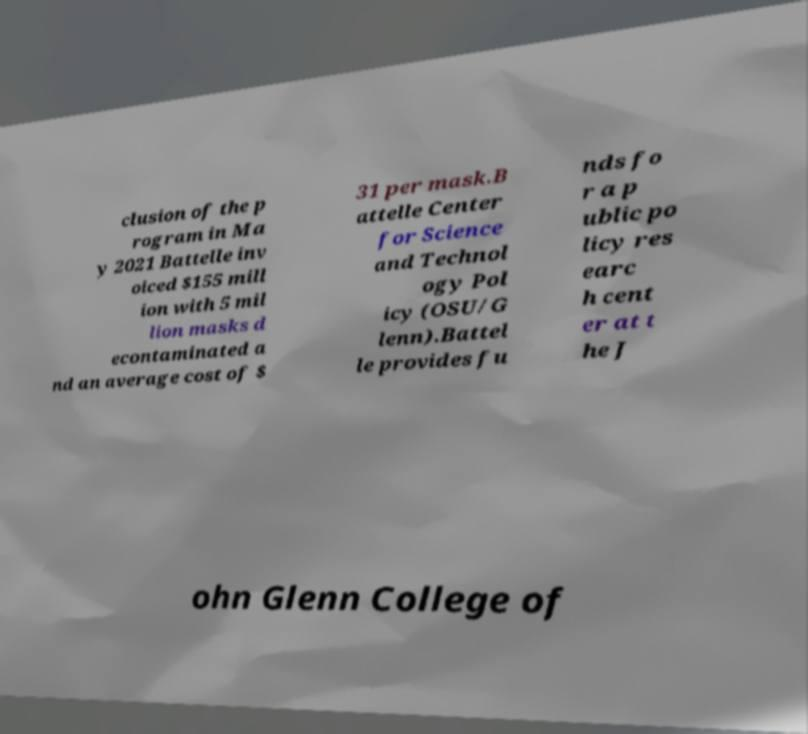Could you assist in decoding the text presented in this image and type it out clearly? clusion of the p rogram in Ma y 2021 Battelle inv oiced $155 mill ion with 5 mil lion masks d econtaminated a nd an average cost of $ 31 per mask.B attelle Center for Science and Technol ogy Pol icy (OSU/G lenn).Battel le provides fu nds fo r a p ublic po licy res earc h cent er at t he J ohn Glenn College of 